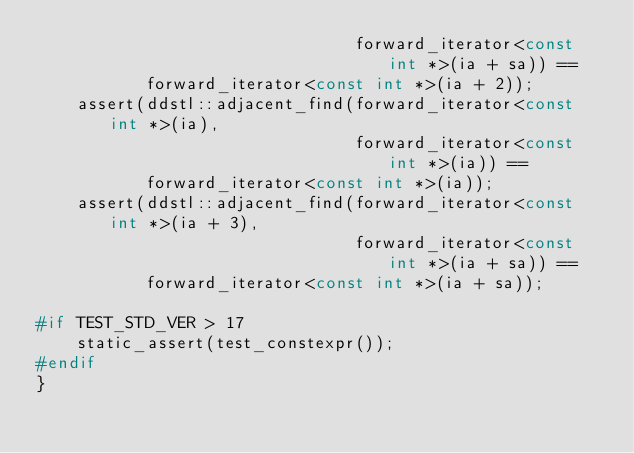<code> <loc_0><loc_0><loc_500><loc_500><_C++_>                                forward_iterator<const int *>(ia + sa)) ==
           forward_iterator<const int *>(ia + 2));
    assert(ddstl::adjacent_find(forward_iterator<const int *>(ia),
                                forward_iterator<const int *>(ia)) ==
           forward_iterator<const int *>(ia));
    assert(ddstl::adjacent_find(forward_iterator<const int *>(ia + 3),
                                forward_iterator<const int *>(ia + sa)) ==
           forward_iterator<const int *>(ia + sa));

#if TEST_STD_VER > 17
    static_assert(test_constexpr());
#endif
}</code> 